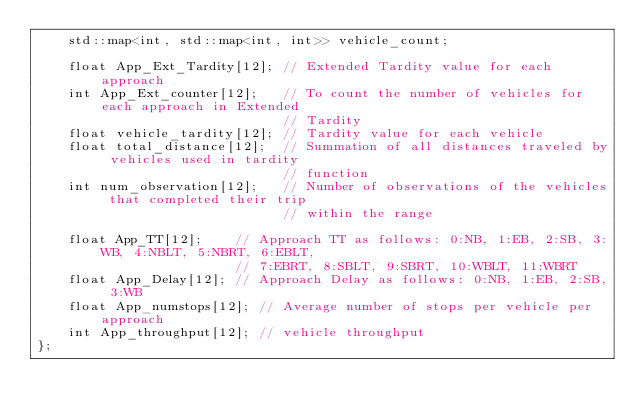Convert code to text. <code><loc_0><loc_0><loc_500><loc_500><_C_>    std::map<int, std::map<int, int>> vehicle_count;

    float App_Ext_Tardity[12]; // Extended Tardity value for each approach
    int App_Ext_counter[12];   // To count the number of vehicles for each approach in Extended
                               // Tardity
    float vehicle_tardity[12]; // Tardity value for each vehicle
    float total_distance[12];  // Summation of all distances traveled by vehicles used in tardity
                               // function
    int num_observation[12];   // Number of observations of the vehicles that completed their trip
                               // within the range

    float App_TT[12];    // Approach TT as follows: 0:NB, 1:EB, 2:SB, 3:WB, 4:NBLT, 5:NBRT, 6:EBLT,
                         // 7:EBRT, 8:SBLT, 9:SBRT, 10:WBLT, 11:WBRT
    float App_Delay[12]; // Approach Delay as follows: 0:NB, 1:EB, 2:SB, 3:WB
    float App_numstops[12]; // Average number of stops per vehicle per approach
    int App_throughput[12]; // vehicle throughput
};
</code> 